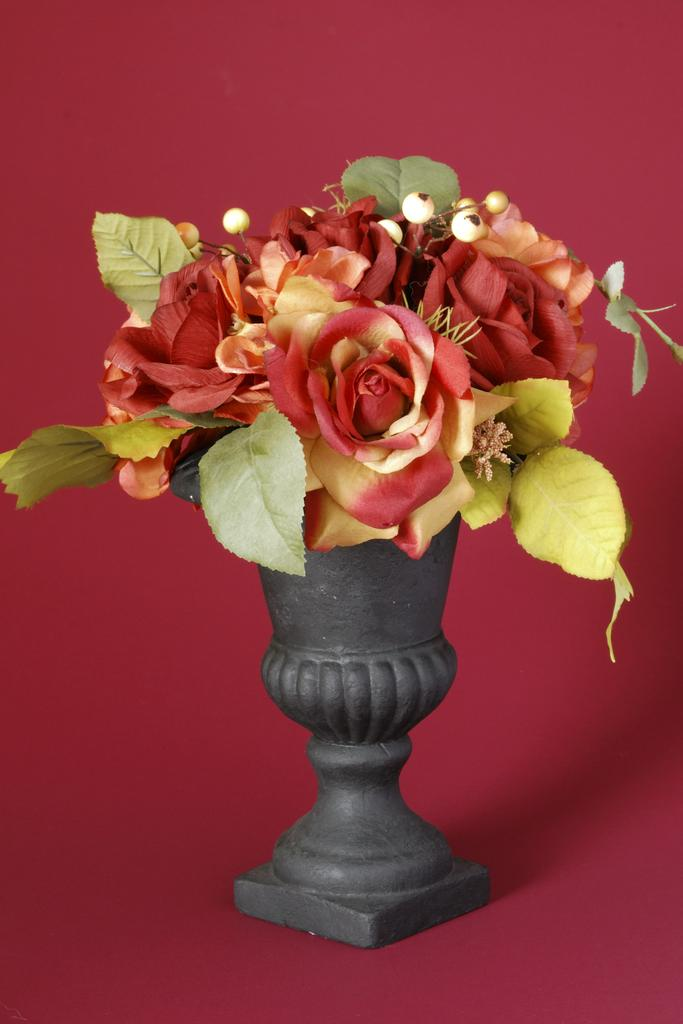What object is present in the image that contains flowers and leaves? There is a flower pot in the image that contains flowers and leaves. What colors can be seen in the background of the image? The background of the image has a red color. Where is the sister of the person who took the picture in the image? There is no person mentioned in the image, so it is impossible to determine the location of a sister. 